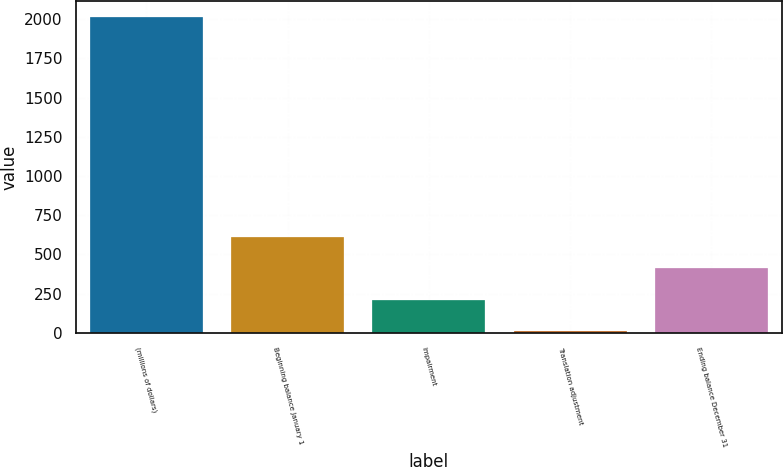<chart> <loc_0><loc_0><loc_500><loc_500><bar_chart><fcel>(millions of dollars)<fcel>Beginning balance January 1<fcel>Impairment<fcel>Translation adjustment<fcel>Ending balance December 31<nl><fcel>2013<fcel>612.58<fcel>212.46<fcel>12.4<fcel>412.52<nl></chart> 